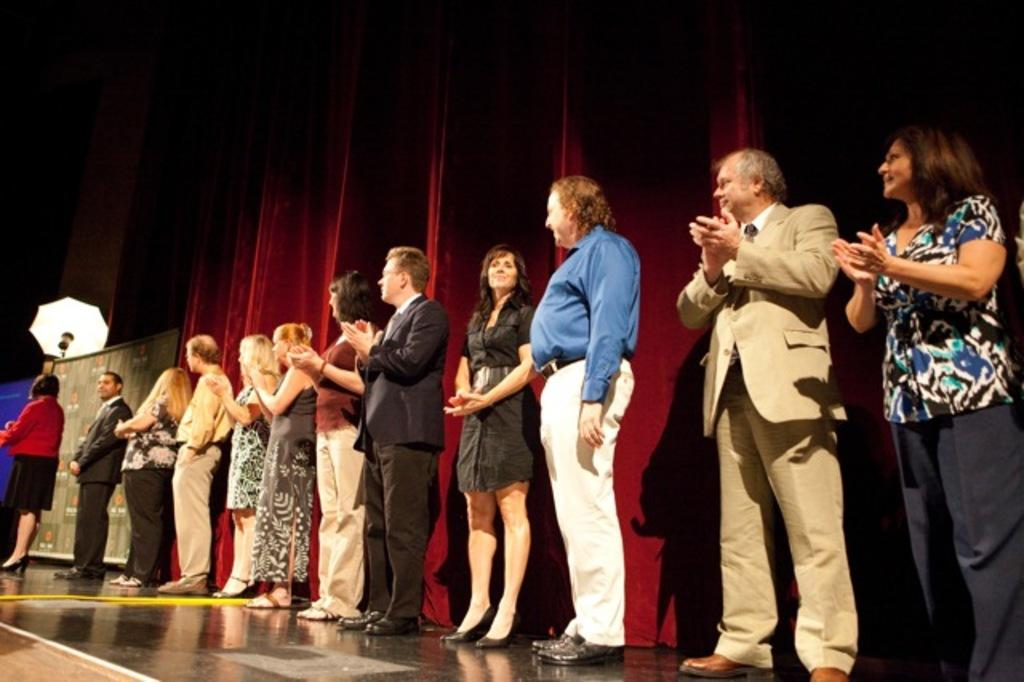What is happening in the image involving the group of people? Some people are clapping their hands in the image. What can be seen in the background of the image? There is a curtain in the background of the image. What is located on the left side of the image? There are banners and an umbrella on the left side of the image. What type of punishment is being administered to the people in the image? There is no indication of punishment in the image; people are clapping their hands. What rhythm are the people clapping to in the image? The image does not provide information about the rhythm of the clapping. 